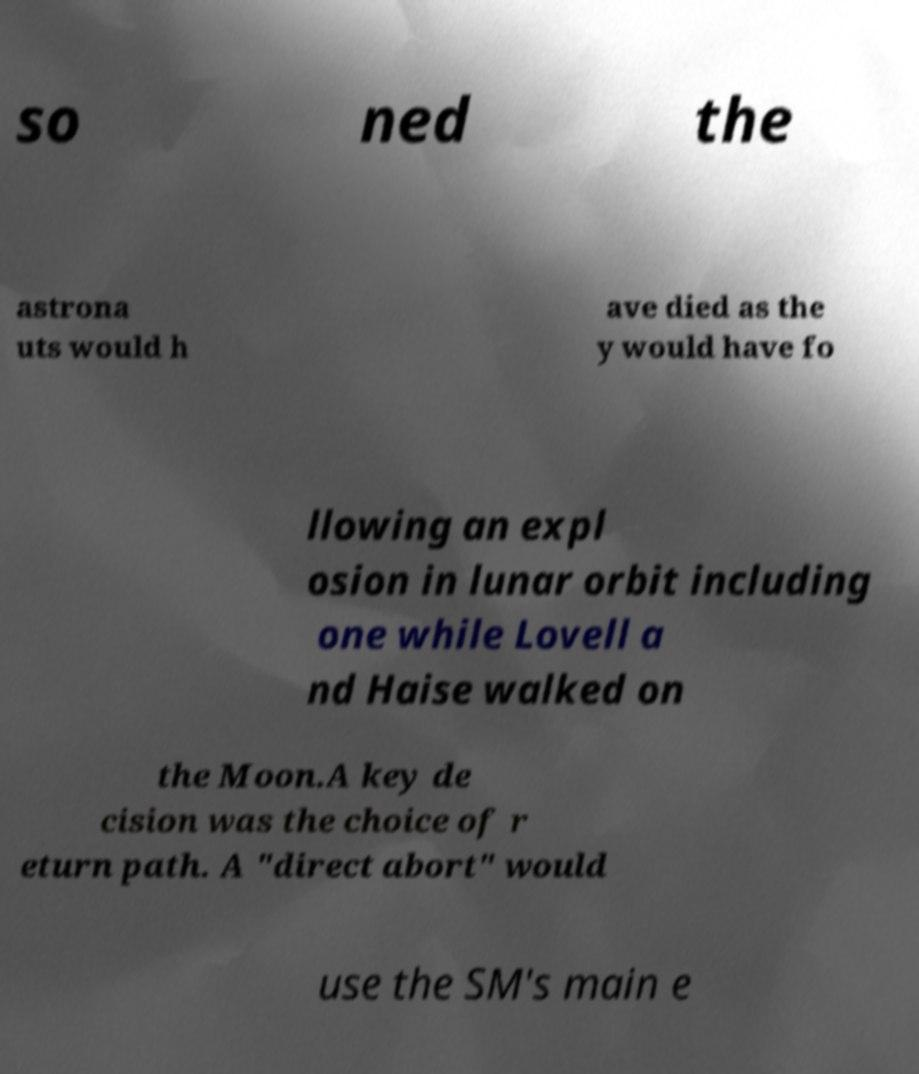There's text embedded in this image that I need extracted. Can you transcribe it verbatim? so ned the astrona uts would h ave died as the y would have fo llowing an expl osion in lunar orbit including one while Lovell a nd Haise walked on the Moon.A key de cision was the choice of r eturn path. A "direct abort" would use the SM's main e 